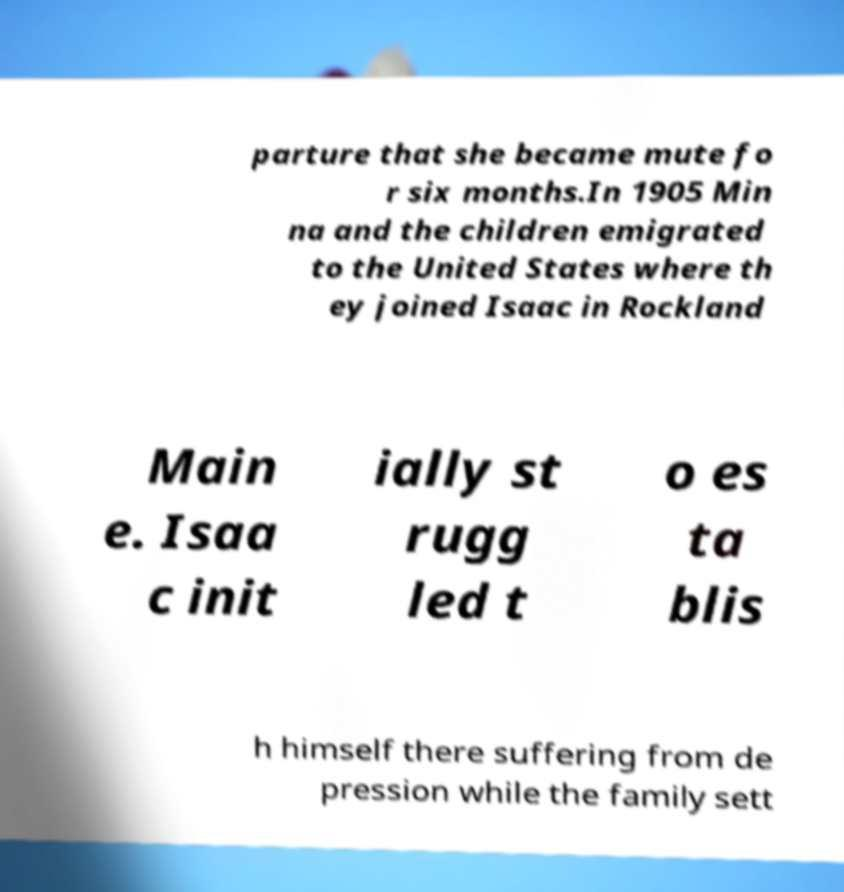What messages or text are displayed in this image? I need them in a readable, typed format. parture that she became mute fo r six months.In 1905 Min na and the children emigrated to the United States where th ey joined Isaac in Rockland Main e. Isaa c init ially st rugg led t o es ta blis h himself there suffering from de pression while the family sett 